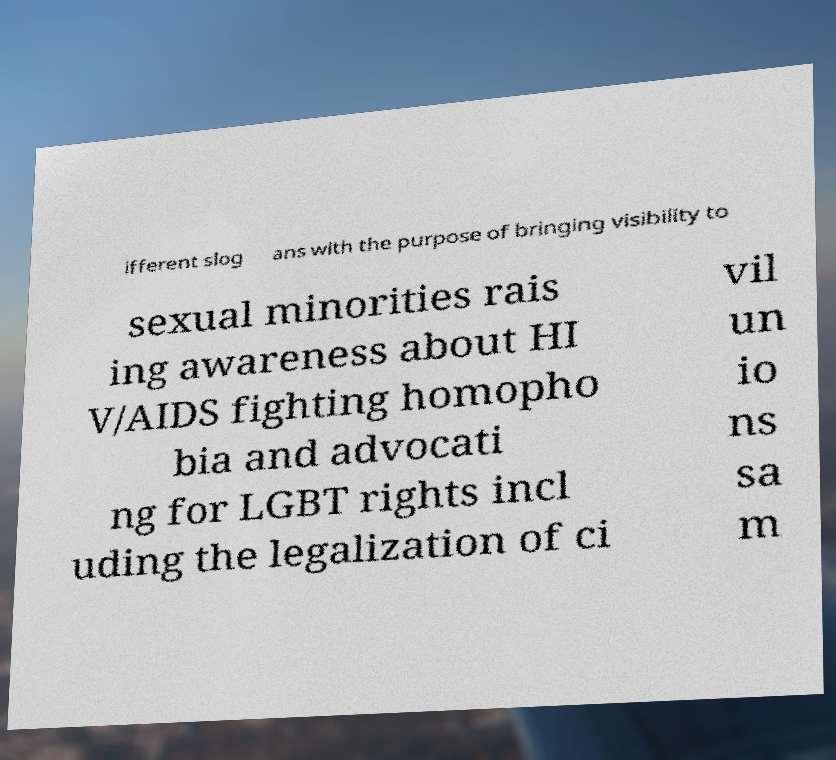Can you accurately transcribe the text from the provided image for me? ifferent slog ans with the purpose of bringing visibility to sexual minorities rais ing awareness about HI V/AIDS fighting homopho bia and advocati ng for LGBT rights incl uding the legalization of ci vil un io ns sa m 